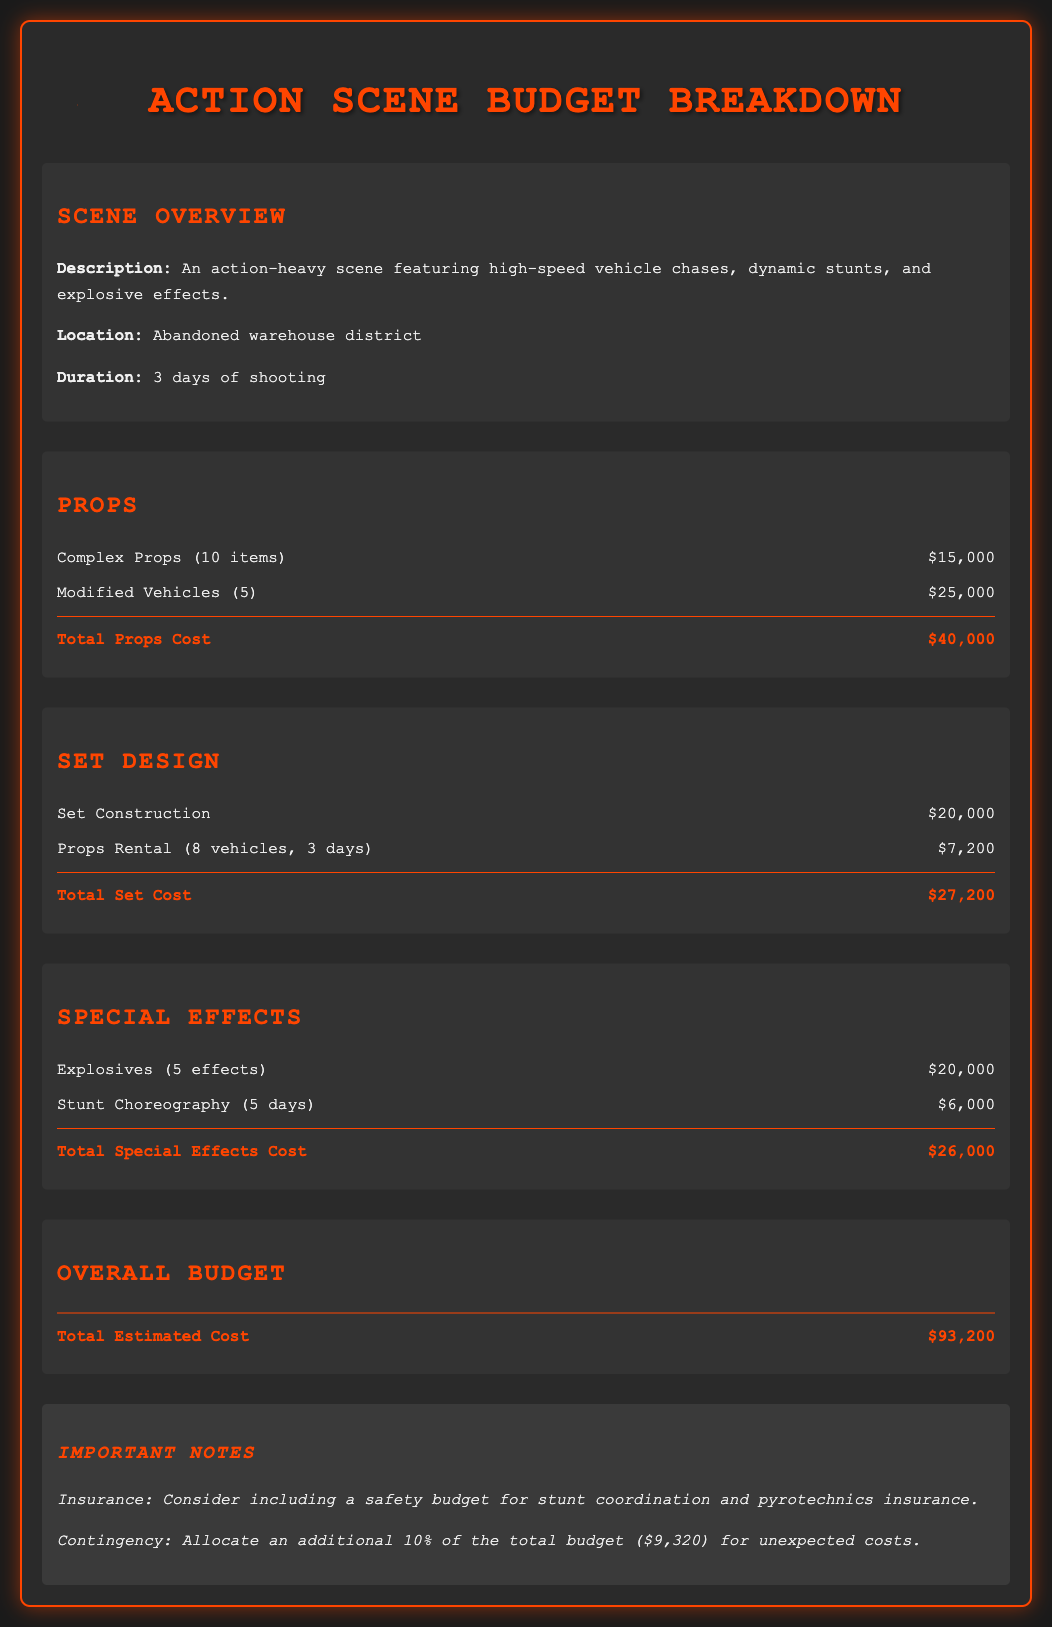What is the total estimated cost? The total estimated cost is presented in the overall budget section as the sum of all costs, which is $93,200.
Answer: $93,200 How many days is the shooting scheduled for? The duration of shooting is provided in the scene overview, which indicates 3 days of shooting.
Answer: 3 days What is the cost of modified vehicles? The cost of modified vehicles is listed under props, showing a cost of $25,000 for 5 vehicles.
Answer: $25,000 How much is allocated for explosives? The budget for explosives can be found in the special effects section, which specifies $20,000 for 5 effects.
Answer: $20,000 What is the total props cost? The total props cost is the sum of complex props and modified vehicles, which totals $40,000.
Answer: $40,000 What percentage for contingency is recommended? The document suggests allocating an additional 10% of the total budget for unexpected costs, as mentioned in the notes.
Answer: 10% How much is spent on stunt choreography? The amount spent on stunt choreography is included in the special effects section, listed as $6,000 for 5 days.
Answer: $6,000 What is the total set cost? The total set cost is derived from set construction and props rental, totaling $27,200 as described in the set design section.
Answer: $27,200 How many complex props are included in the scene? The number of complex props is indicated in the props section, stating there are 10 complex props.
Answer: 10 items 